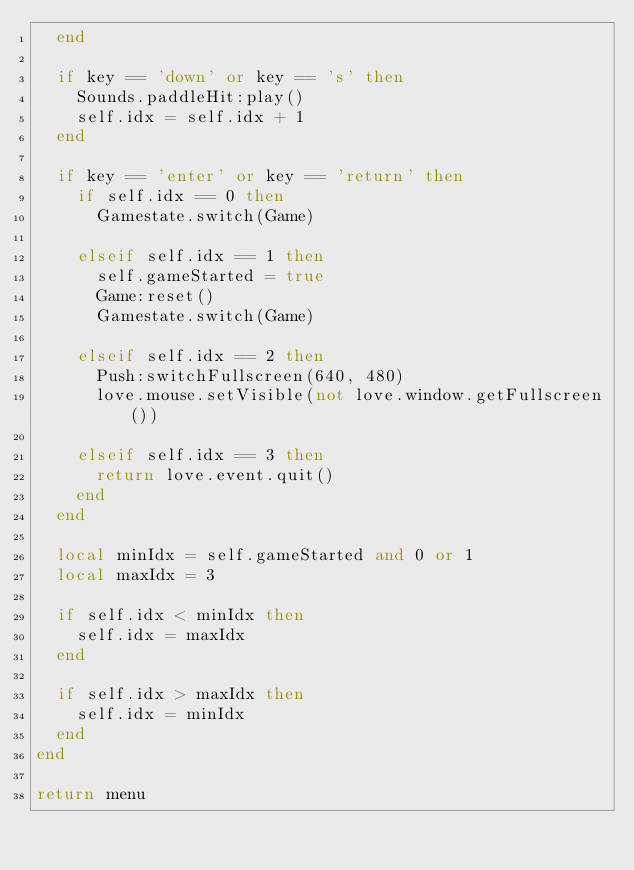Convert code to text. <code><loc_0><loc_0><loc_500><loc_500><_Lua_>  end

  if key == 'down' or key == 's' then
    Sounds.paddleHit:play()
    self.idx = self.idx + 1
  end

  if key == 'enter' or key == 'return' then
    if self.idx == 0 then
      Gamestate.switch(Game)

    elseif self.idx == 1 then
      self.gameStarted = true
      Game:reset()
      Gamestate.switch(Game)

    elseif self.idx == 2 then
      Push:switchFullscreen(640, 480)
      love.mouse.setVisible(not love.window.getFullscreen())

    elseif self.idx == 3 then
      return love.event.quit()
    end
  end

  local minIdx = self.gameStarted and 0 or 1
  local maxIdx = 3

  if self.idx < minIdx then
    self.idx = maxIdx
  end

  if self.idx > maxIdx then
    self.idx = minIdx
  end
end

return menu
</code> 